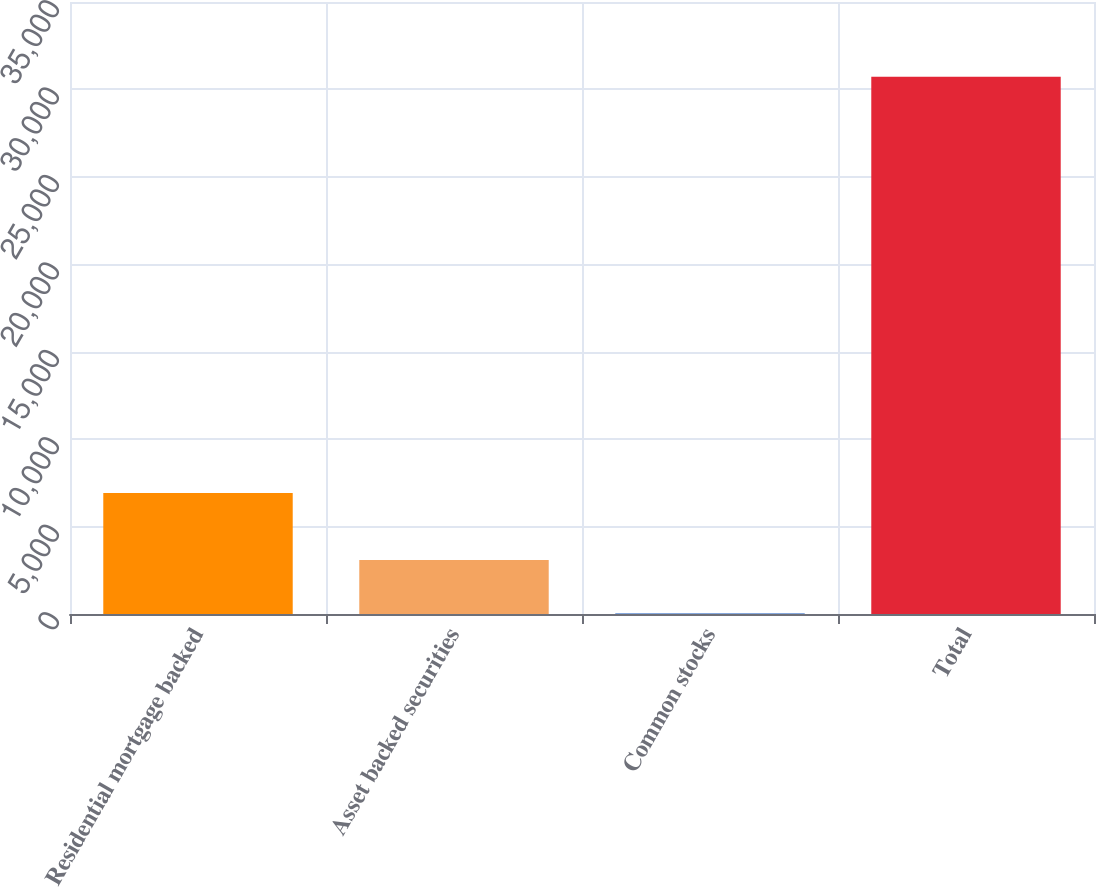Convert chart to OTSL. <chart><loc_0><loc_0><loc_500><loc_500><bar_chart><fcel>Residential mortgage backed<fcel>Asset backed securities<fcel>Common stocks<fcel>Total<nl><fcel>6918<fcel>3091.7<fcel>22<fcel>30719<nl></chart> 